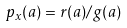<formula> <loc_0><loc_0><loc_500><loc_500>p _ { x } ( a ) = r ( a ) / g ( a )</formula> 